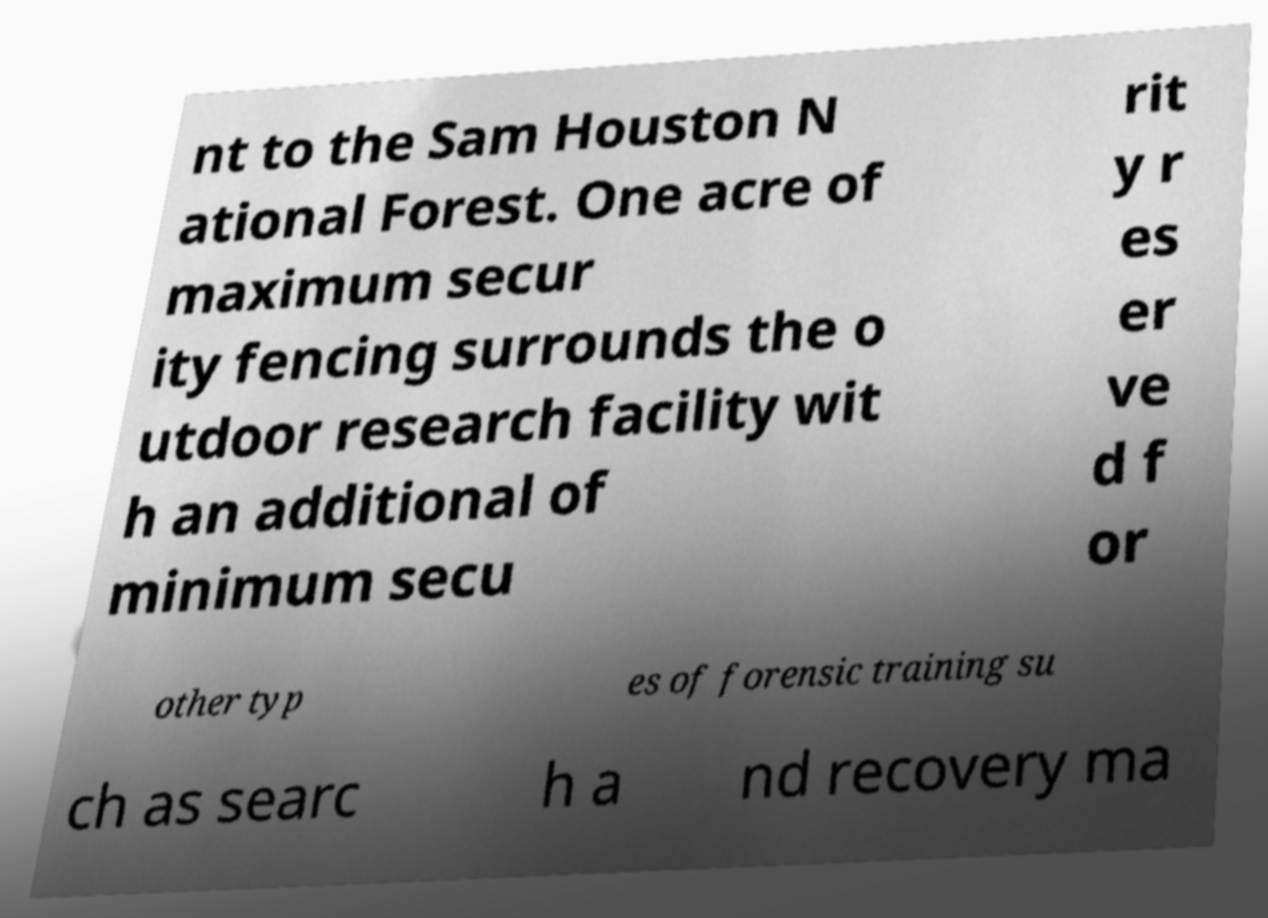There's text embedded in this image that I need extracted. Can you transcribe it verbatim? nt to the Sam Houston N ational Forest. One acre of maximum secur ity fencing surrounds the o utdoor research facility wit h an additional of minimum secu rit y r es er ve d f or other typ es of forensic training su ch as searc h a nd recovery ma 